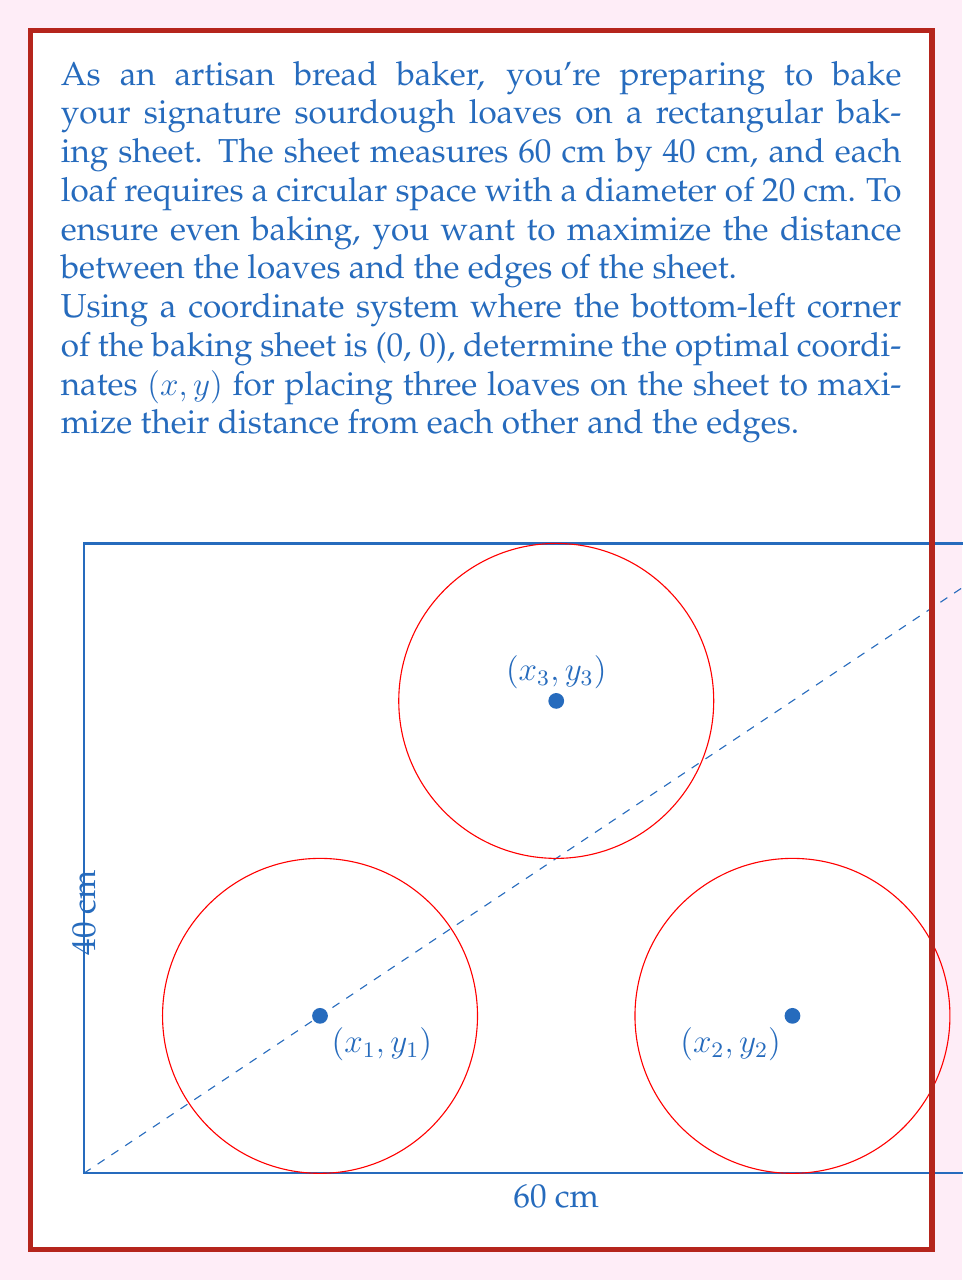Can you solve this math problem? Let's approach this step-by-step:

1) Given the rectangular shape of the baking sheet, we can use symmetry to our advantage. The optimal placement will likely be in a triangular formation.

2) To maximize distance from the edges, we'll place the loaves' centers 10 cm (half the diameter) away from the nearest edges.

3) For the bottom two loaves:
   x₁ = 10 cm (from left edge)
   x₂ = 60 - 10 = 50 cm (from right edge)
   y₁ = y₂ = 10 cm (from bottom edge)

4) For the top loaf:
   x₃ = 60 ÷ 2 = 30 cm (centered horizontally)
   y₃ = 40 - 10 = 30 cm (from top edge)

5) Let's verify the distance between loaves:
   Distance = $\sqrt{(x_2 - x_1)^2 + (y_2 - y_1)^2}$
             = $\sqrt{(50 - 10)^2 + (10 - 10)^2}$
             = $\sqrt{1600} = 40$ cm

   This is exactly twice the diameter of each loaf, ensuring they don't overlap.

6) The distance from the top loaf to each bottom loaf is:
   $\sqrt{(30 - 10)^2 + (30 - 10)^2} = \sqrt{800} \approx 28.28$ cm

   This is greater than the diameter of the loaves, ensuring no overlap.

Therefore, the optimal coordinates for the three loaves are:
(10, 10), (50, 10), and (30, 30)
Answer: (10, 10), (50, 10), (30, 30) 